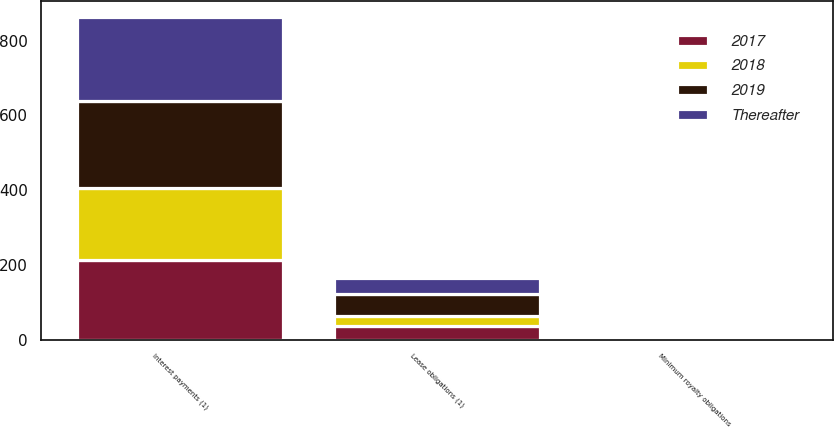<chart> <loc_0><loc_0><loc_500><loc_500><stacked_bar_chart><ecel><fcel>Interest payments (1)<fcel>Lease obligations (1)<fcel>Minimum royalty obligations<nl><fcel>2019<fcel>232<fcel>58<fcel>4<nl><fcel>Thereafter<fcel>225<fcel>44<fcel>4<nl><fcel>2017<fcel>214<fcel>36<fcel>4<nl><fcel>2018<fcel>192<fcel>27<fcel>4<nl></chart> 